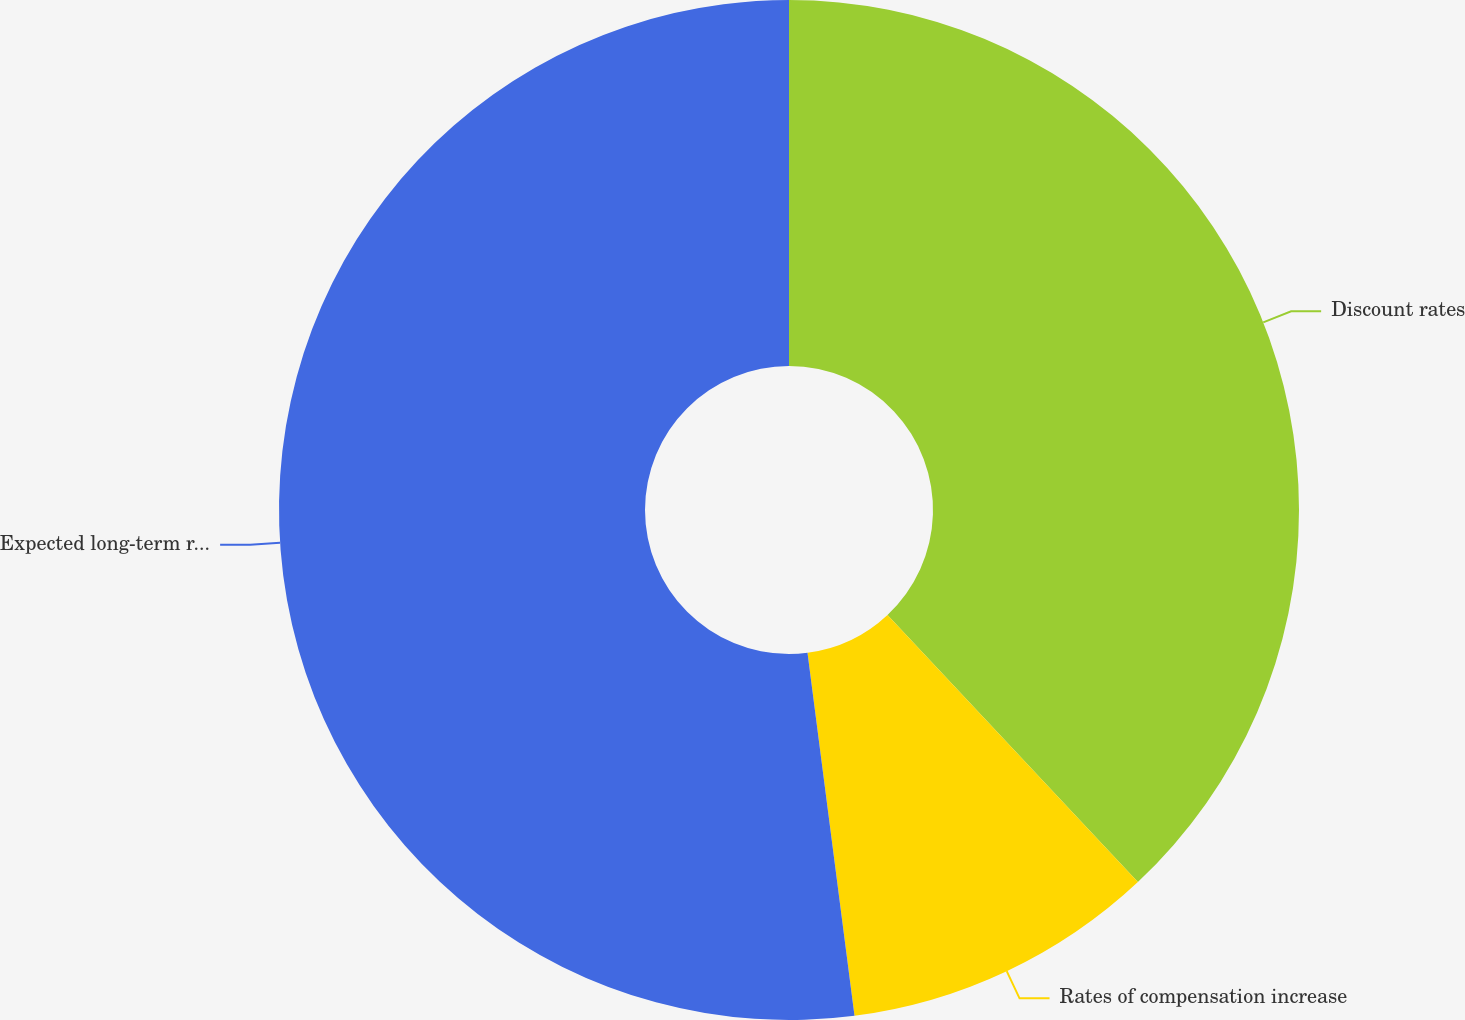Convert chart. <chart><loc_0><loc_0><loc_500><loc_500><pie_chart><fcel>Discount rates<fcel>Rates of compensation increase<fcel>Expected long-term rate of<nl><fcel>38.01%<fcel>9.94%<fcel>52.05%<nl></chart> 